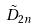<formula> <loc_0><loc_0><loc_500><loc_500>\tilde { D } _ { 2 n }</formula> 